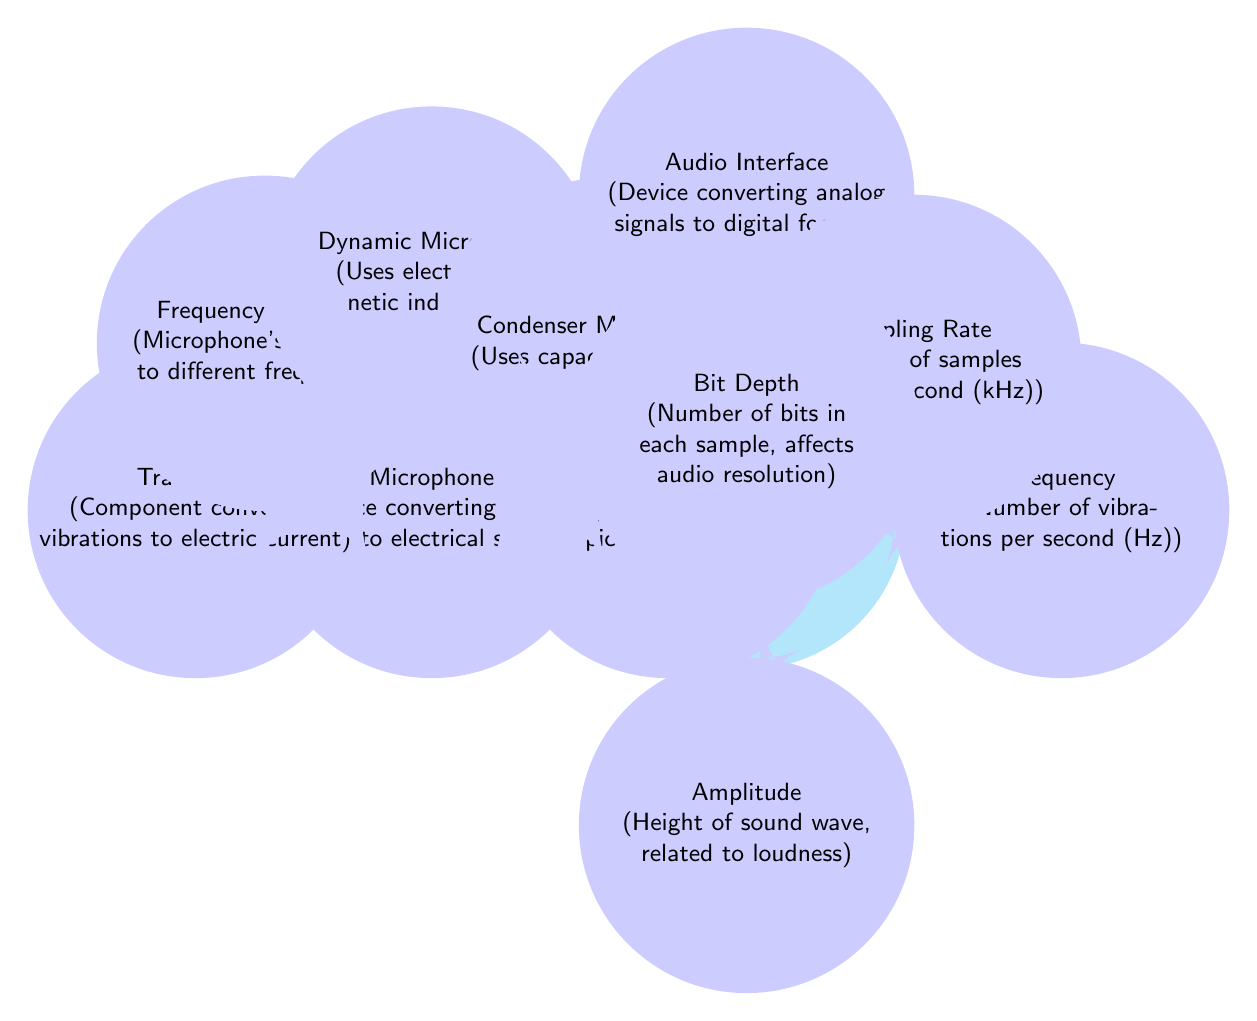What is the main concept represented in the diagram? The main concept is "Sound Waves," which describes vibrations traveling through the air.
Answer: Sound Waves How many child nodes does the "Microphone" node have? The "Microphone" node has five child nodes: Transducer, Frequency Response, Dynamic Microphone, Condenser Microphone, and Directionality.
Answer: 5 What does the "Sampling Rate" refer to? The "Sampling Rate" refers to the number of samples taken per second, measured in kilohertz (kHz).
Answer: Number of samples taken per second (kHz) Which type of microphone uses electromagnetic induction? The type of microphone that uses electromagnetic induction is the "Dynamic Microphone."
Answer: Dynamic Microphone What relationship do "Frequency" and "Amplitude" have with "Sound Waves"? Both "Frequency" and "Amplitude" are child nodes of "Sound Waves," indicating they are properties or characteristics of sound waves.
Answer: They are properties of sound waves What does "Bit Depth" affect according to the diagram? "Bit Depth" affects the audio resolution of each sample taken by the audio interface.
Answer: Audio resolution Which node connects "Microphone" to "Audio Interface"? The "Microphone" node connects to the "Audio Interface" node directly, indicating a flow from sound capture to signal processing.
Answer: Audio Interface Describe the concept of "Directionality" in relation to microphones. "Directionality" refers to the microphone's pickup pattern, indicating how well it picks up sound from different directions.
Answer: Microphone's pickup pattern What is the significance of "Frequency Response" in a microphone? "Frequency Response" is significant as it indicates the microphone's sensitivity to different frequencies, affecting how sound is captured.
Answer: Sensitivity to different frequencies 